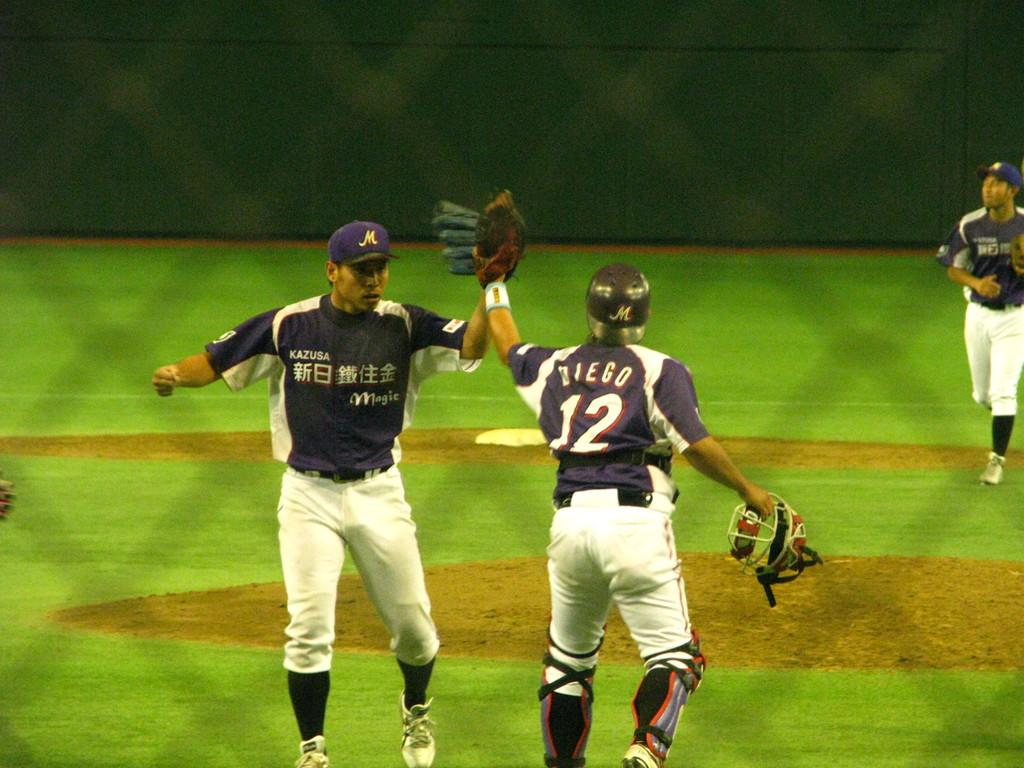<image>
Present a compact description of the photo's key features. Baseball players from KAZUSA Magic face each other on the baseball field. 